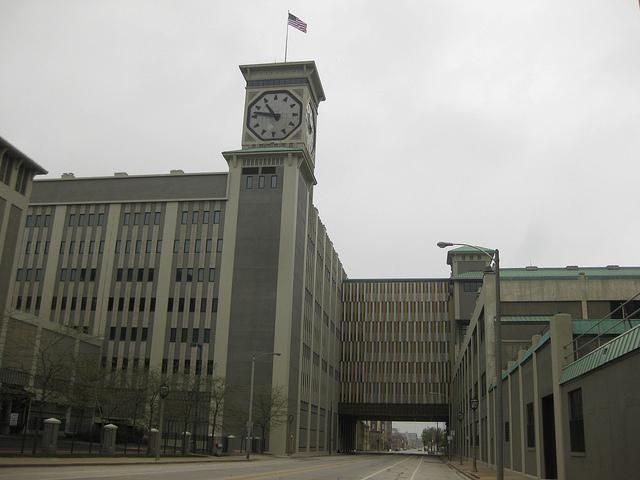How many people are on the roof?
Give a very brief answer. 0. How many scrolls beneath the lamp are oriented like the letter S?
Give a very brief answer. 0. How many elephants are pictured?
Give a very brief answer. 0. 